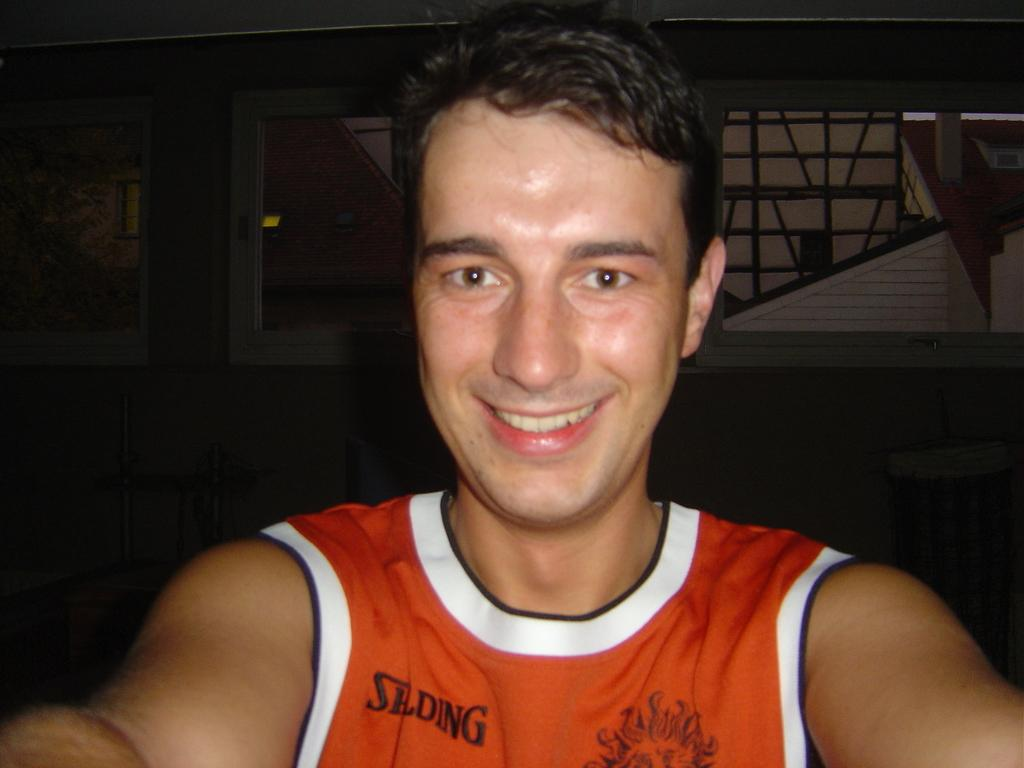<image>
Share a concise interpretation of the image provided. A man is wearing a orange shirt with the the letters SLDWG on his right of his shirt. 